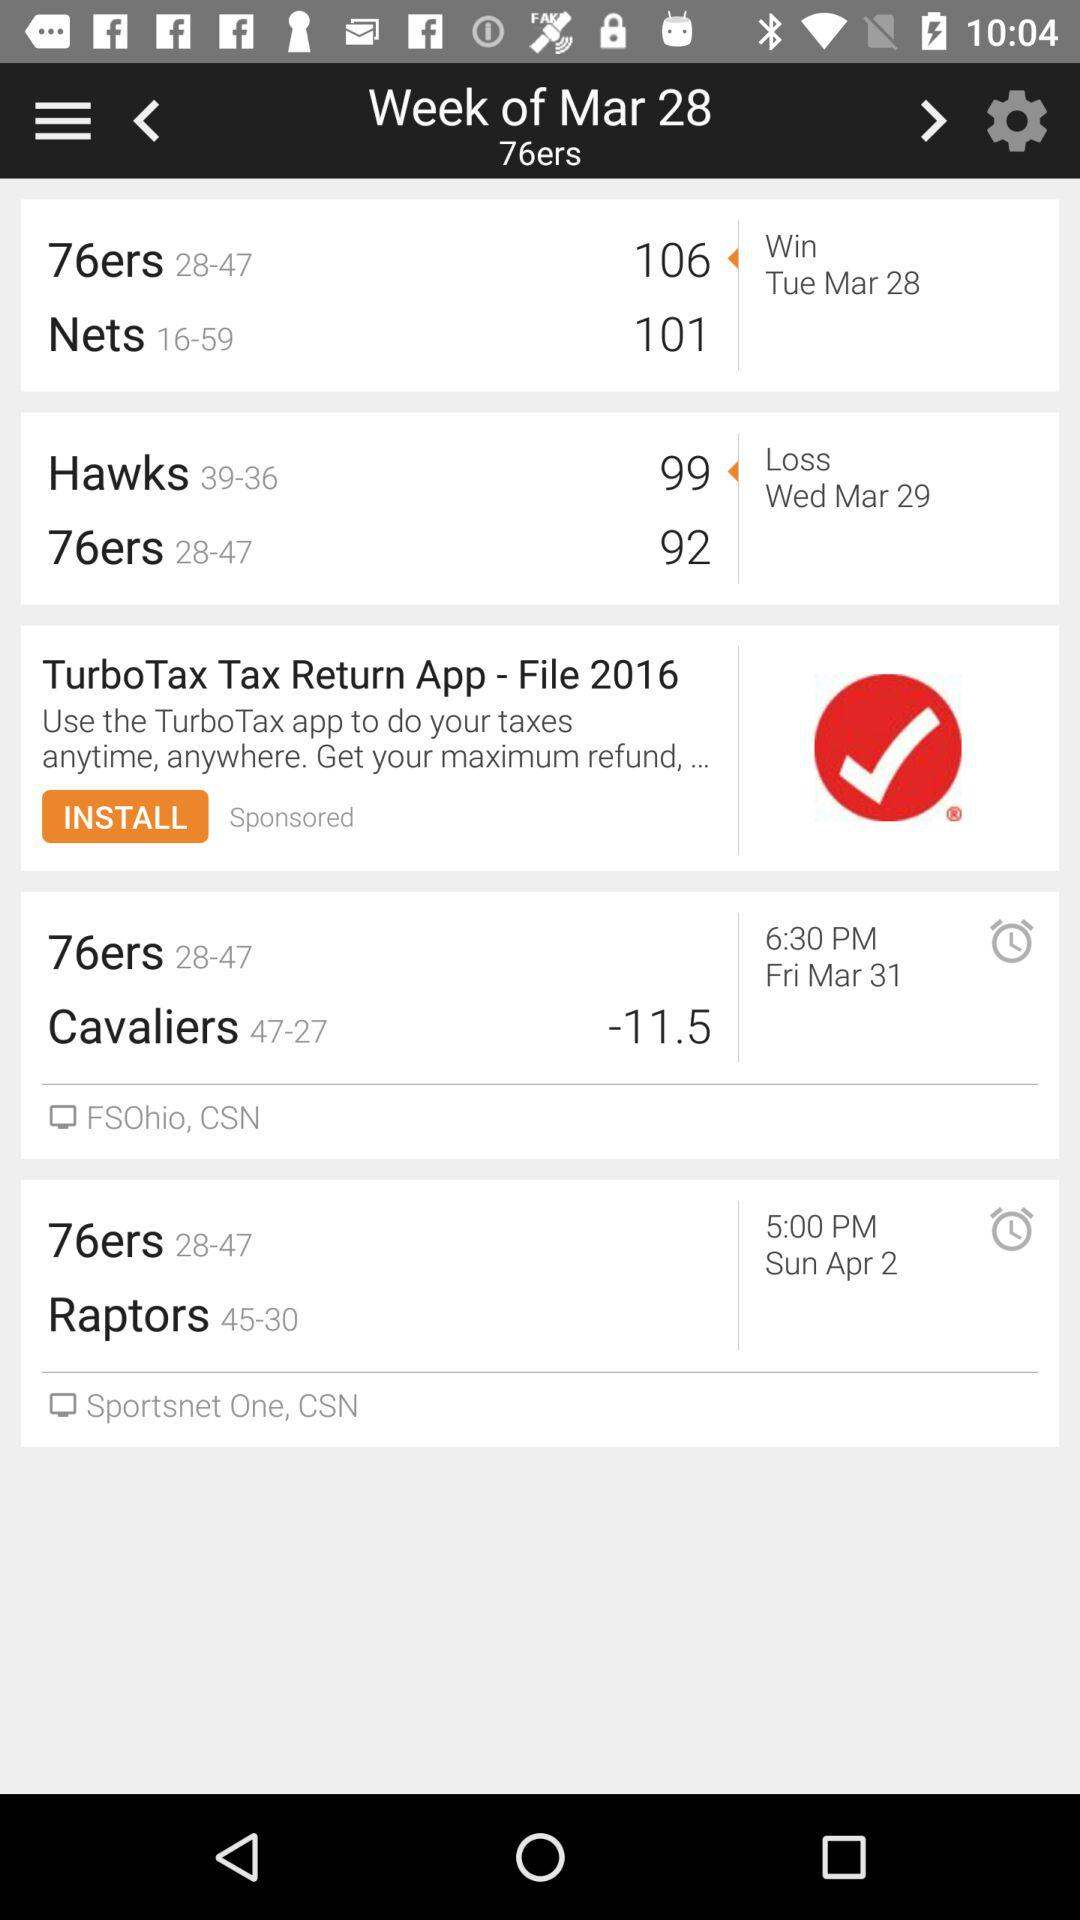How many games have the Raptors won?
Answer the question using a single word or phrase. 45 